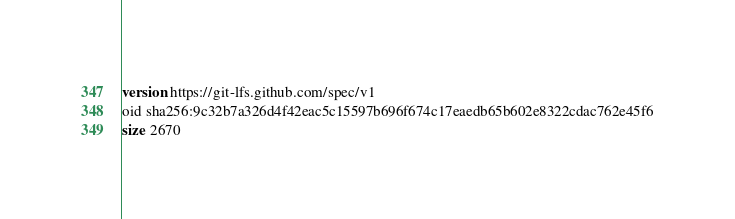<code> <loc_0><loc_0><loc_500><loc_500><_SQL_>version https://git-lfs.github.com/spec/v1
oid sha256:9c32b7a326d4f42eac5c15597b696f674c17eaedb65b602e8322cdac762e45f6
size 2670
</code> 